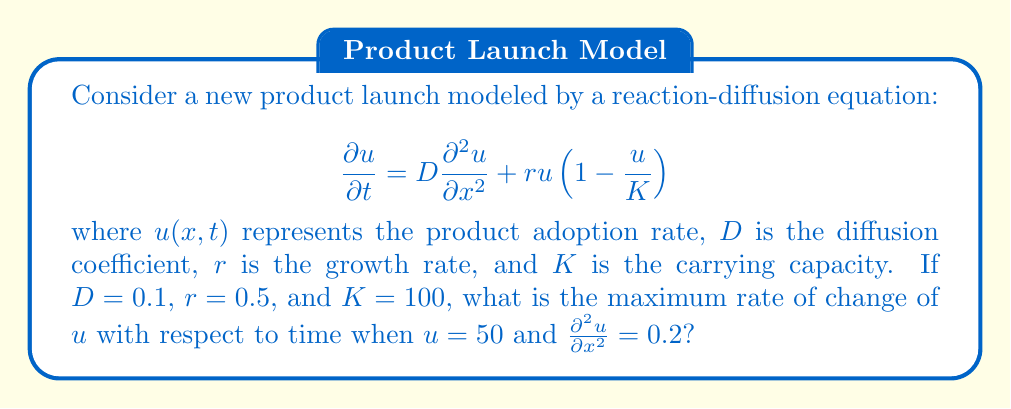Can you solve this math problem? To solve this problem, we need to follow these steps:

1) The reaction-diffusion equation given is:

   $$\frac{\partial u}{\partial t} = D\frac{\partial^2 u}{\partial x^2} + ru(1-\frac{u}{K})$$

2) We're asked to find the maximum rate of change of $u$ with respect to time, which is $\frac{\partial u}{\partial t}$.

3) We're given the following values:
   - $D = 0.1$
   - $r = 0.5$
   - $K = 100$
   - $u = 50$
   - $\frac{\partial^2 u}{\partial x^2} = 0.2$

4) Let's substitute these values into the equation:

   $$\frac{\partial u}{\partial t} = 0.1(0.2) + 0.5(50)(1-\frac{50}{100})$$

5) Let's solve the right side step by step:
   
   a) First term: $0.1(0.2) = 0.02$
   
   b) Second term: $0.5(50)(1-\frac{50}{100}) = 0.5(50)(0.5) = 12.5$

6) Now, add these terms:

   $$\frac{\partial u}{\partial t} = 0.02 + 12.5 = 12.52$$

This is the maximum rate of change of $u$ with respect to time under the given conditions.
Answer: $12.52$ 